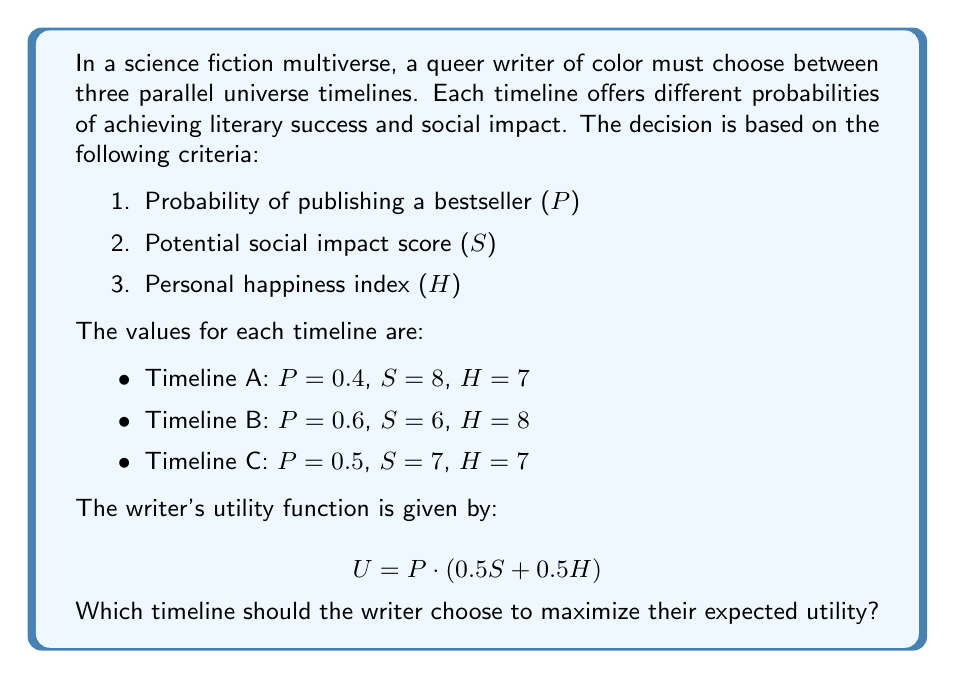What is the answer to this math problem? To solve this problem, we need to calculate the expected utility for each timeline using the given utility function and compare the results. Let's go through this step-by-step:

1. Utility function:
   $$ U = P \cdot (0.5S + 0.5H) $$

2. Calculate the utility for Timeline A:
   $$ U_A = 0.4 \cdot (0.5 \cdot 8 + 0.5 \cdot 7) $$
   $$ U_A = 0.4 \cdot (4 + 3.5) $$
   $$ U_A = 0.4 \cdot 7.5 = 3 $$

3. Calculate the utility for Timeline B:
   $$ U_B = 0.6 \cdot (0.5 \cdot 6 + 0.5 \cdot 8) $$
   $$ U_B = 0.6 \cdot (3 + 4) $$
   $$ U_B = 0.6 \cdot 7 = 4.2 $$

4. Calculate the utility for Timeline C:
   $$ U_C = 0.5 \cdot (0.5 \cdot 7 + 0.5 \cdot 7) $$
   $$ U_C = 0.5 \cdot (3.5 + 3.5) $$
   $$ U_C = 0.5 \cdot 7 = 3.5 $$

5. Compare the utilities:
   $U_A = 3$
   $U_B = 4.2$
   $U_C = 3.5$

The highest utility is achieved by Timeline B with a value of 4.2.
Answer: The writer should choose Timeline B to maximize their expected utility, with a utility value of 4.2. 